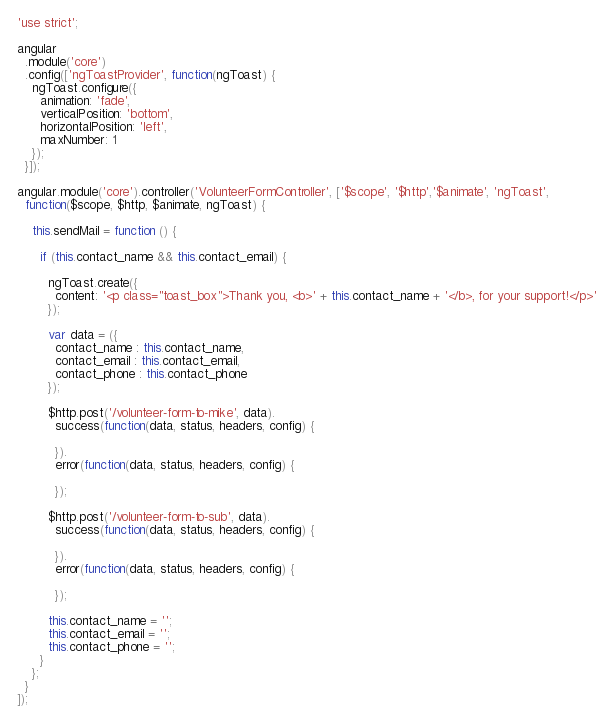<code> <loc_0><loc_0><loc_500><loc_500><_JavaScript_>'use strict';

angular
  .module('core')
  .config(['ngToastProvider', function(ngToast) {
    ngToast.configure({
      animation: 'fade',
      verticalPosition: 'bottom',
      horizontalPosition: 'left',
      maxNumber: 1
    });
  }]);

angular.module('core').controller('VolunteerFormController', ['$scope', '$http','$animate', 'ngToast',
  function($scope, $http, $animate, ngToast) {

    this.sendMail = function () {

      if (this.contact_name && this.contact_email) {

        ngToast.create({
          content: '<p class="toast_box">Thank you, <b>' + this.contact_name + '</b>, for your support!</p>'
        });
      
        var data = ({
          contact_name : this.contact_name,
          contact_email : this.contact_email,
          contact_phone : this.contact_phone
        });

        $http.post('/volunteer-form-to-mike', data).
          success(function(data, status, headers, config) {
            
          }).
          error(function(data, status, headers, config) {

          });

        $http.post('/volunteer-form-to-sub', data).
          success(function(data, status, headers, config) {

          }).
          error(function(data, status, headers, config) {

          });

        this.contact_name = ''; 
        this.contact_email = '';
        this.contact_phone = '';
      }    
    };
  }
]);</code> 